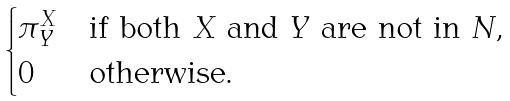Convert formula to latex. <formula><loc_0><loc_0><loc_500><loc_500>\begin{cases} \pi ^ { X } _ { Y } & \text {if both $X$ and $Y$ are not in $N$,} \\ 0 & \text {otherwise.} \end{cases}</formula> 